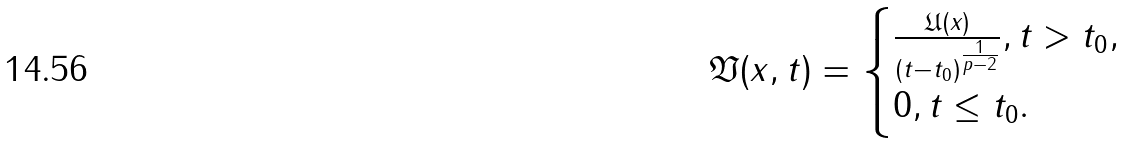<formula> <loc_0><loc_0><loc_500><loc_500>\mathfrak { V } ( x , t ) = \begin{cases} \frac { \mathfrak { U } ( x ) } { ( t - t _ { 0 } ) ^ { \frac { 1 } { p - 2 } } } , t > t _ { 0 } , \\ 0 , t \leq t _ { 0 } . \end{cases}</formula> 